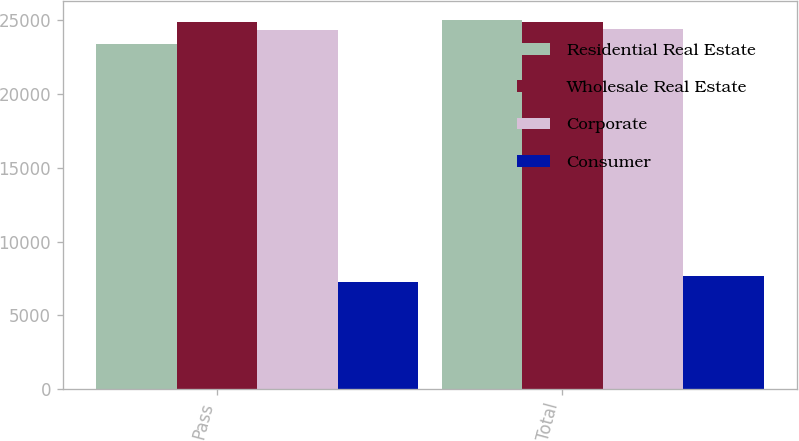Convert chart. <chart><loc_0><loc_0><loc_500><loc_500><stacked_bar_chart><ecel><fcel>Pass<fcel>Total<nl><fcel>Residential Real Estate<fcel>23409<fcel>25025<nl><fcel>Wholesale Real Estate<fcel>24853<fcel>24866<nl><fcel>Corporate<fcel>24345<fcel>24385<nl><fcel>Consumer<fcel>7294<fcel>7702<nl></chart> 